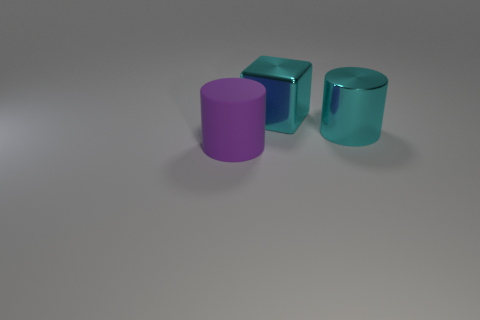What is the material of the big cylinder that is the same color as the big shiny cube?
Ensure brevity in your answer.  Metal. There is a purple object that is the same size as the cube; what is its shape?
Your answer should be compact. Cylinder. Are there any blue objects that have the same shape as the purple rubber object?
Give a very brief answer. No. Is the size of the cylinder behind the purple cylinder the same as the large matte cylinder?
Your answer should be compact. Yes. There is a object that is behind the purple thing and to the left of the metallic cylinder; how big is it?
Provide a succinct answer. Large. What number of other objects are there of the same material as the big cube?
Your answer should be very brief. 1. What size is the cylinder that is behind the purple rubber cylinder?
Your response must be concise. Large. Does the large shiny block have the same color as the large matte thing?
Give a very brief answer. No. What number of tiny things are either purple objects or red cylinders?
Your response must be concise. 0. Are there any other things that are the same color as the metallic cylinder?
Give a very brief answer. Yes. 